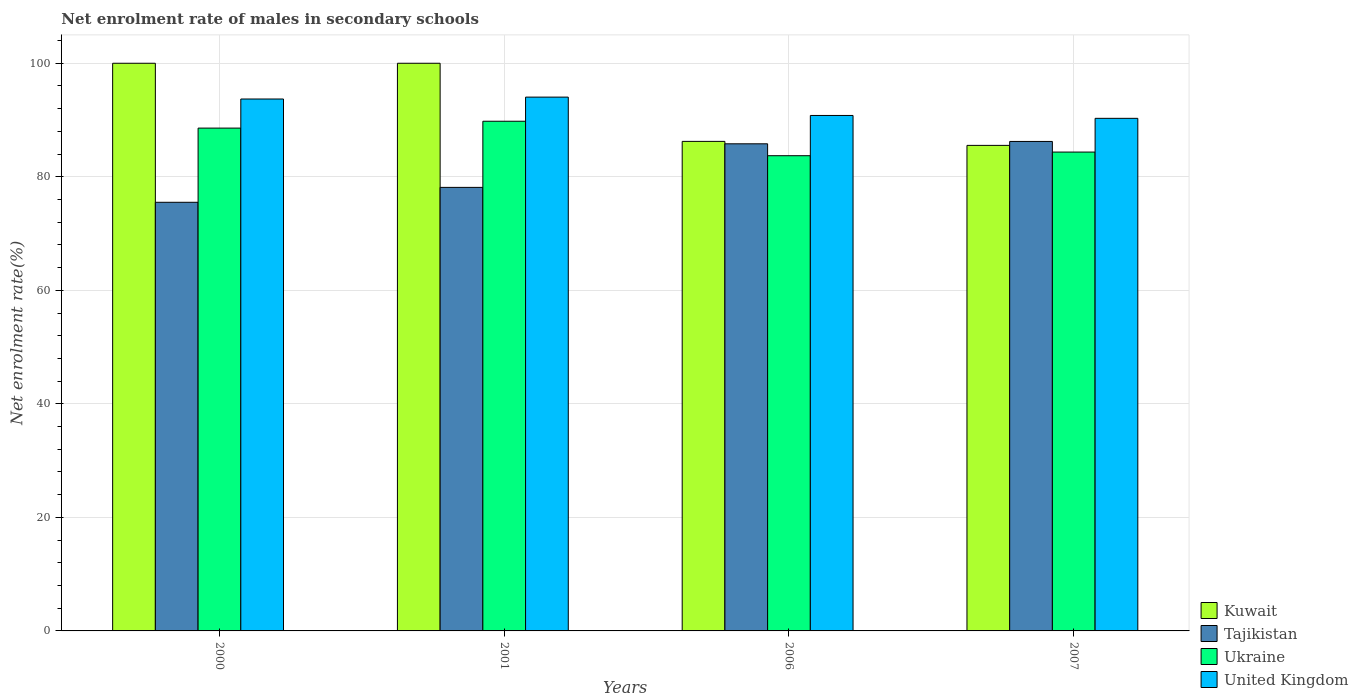Are the number of bars per tick equal to the number of legend labels?
Your response must be concise. Yes. What is the label of the 1st group of bars from the left?
Provide a short and direct response. 2000. What is the net enrolment rate of males in secondary schools in United Kingdom in 2006?
Your answer should be compact. 90.8. Across all years, what is the maximum net enrolment rate of males in secondary schools in Ukraine?
Provide a succinct answer. 89.79. Across all years, what is the minimum net enrolment rate of males in secondary schools in Tajikistan?
Keep it short and to the point. 75.51. In which year was the net enrolment rate of males in secondary schools in Tajikistan minimum?
Provide a short and direct response. 2000. What is the total net enrolment rate of males in secondary schools in Kuwait in the graph?
Your answer should be very brief. 371.77. What is the difference between the net enrolment rate of males in secondary schools in Ukraine in 2000 and that in 2007?
Your response must be concise. 4.22. What is the difference between the net enrolment rate of males in secondary schools in Kuwait in 2000 and the net enrolment rate of males in secondary schools in Tajikistan in 2007?
Offer a very short reply. 13.77. What is the average net enrolment rate of males in secondary schools in Kuwait per year?
Offer a very short reply. 92.94. In the year 2007, what is the difference between the net enrolment rate of males in secondary schools in Tajikistan and net enrolment rate of males in secondary schools in Kuwait?
Your response must be concise. 0.69. What is the ratio of the net enrolment rate of males in secondary schools in Kuwait in 2000 to that in 2006?
Your answer should be very brief. 1.16. Is the net enrolment rate of males in secondary schools in Kuwait in 2000 less than that in 2006?
Give a very brief answer. No. Is the difference between the net enrolment rate of males in secondary schools in Tajikistan in 2001 and 2007 greater than the difference between the net enrolment rate of males in secondary schools in Kuwait in 2001 and 2007?
Offer a very short reply. No. What is the difference between the highest and the second highest net enrolment rate of males in secondary schools in Ukraine?
Offer a very short reply. 1.21. What is the difference between the highest and the lowest net enrolment rate of males in secondary schools in Ukraine?
Your answer should be very brief. 6.07. In how many years, is the net enrolment rate of males in secondary schools in Kuwait greater than the average net enrolment rate of males in secondary schools in Kuwait taken over all years?
Your answer should be very brief. 2. Is the sum of the net enrolment rate of males in secondary schools in Tajikistan in 2000 and 2007 greater than the maximum net enrolment rate of males in secondary schools in Ukraine across all years?
Offer a very short reply. Yes. What does the 2nd bar from the left in 2006 represents?
Give a very brief answer. Tajikistan. What does the 2nd bar from the right in 2006 represents?
Your answer should be compact. Ukraine. How many bars are there?
Ensure brevity in your answer.  16. Are the values on the major ticks of Y-axis written in scientific E-notation?
Your answer should be compact. No. Does the graph contain any zero values?
Make the answer very short. No. Where does the legend appear in the graph?
Give a very brief answer. Bottom right. What is the title of the graph?
Give a very brief answer. Net enrolment rate of males in secondary schools. What is the label or title of the X-axis?
Your answer should be very brief. Years. What is the label or title of the Y-axis?
Provide a succinct answer. Net enrolment rate(%). What is the Net enrolment rate(%) in Tajikistan in 2000?
Make the answer very short. 75.51. What is the Net enrolment rate(%) of Ukraine in 2000?
Provide a short and direct response. 88.58. What is the Net enrolment rate(%) of United Kingdom in 2000?
Offer a terse response. 93.7. What is the Net enrolment rate(%) of Tajikistan in 2001?
Ensure brevity in your answer.  78.13. What is the Net enrolment rate(%) in Ukraine in 2001?
Give a very brief answer. 89.79. What is the Net enrolment rate(%) of United Kingdom in 2001?
Provide a short and direct response. 94.04. What is the Net enrolment rate(%) of Kuwait in 2006?
Provide a succinct answer. 86.24. What is the Net enrolment rate(%) of Tajikistan in 2006?
Provide a succinct answer. 85.81. What is the Net enrolment rate(%) of Ukraine in 2006?
Your response must be concise. 83.71. What is the Net enrolment rate(%) of United Kingdom in 2006?
Provide a short and direct response. 90.8. What is the Net enrolment rate(%) in Kuwait in 2007?
Provide a succinct answer. 85.53. What is the Net enrolment rate(%) in Tajikistan in 2007?
Your answer should be compact. 86.23. What is the Net enrolment rate(%) of Ukraine in 2007?
Provide a succinct answer. 84.36. What is the Net enrolment rate(%) of United Kingdom in 2007?
Ensure brevity in your answer.  90.3. Across all years, what is the maximum Net enrolment rate(%) in Kuwait?
Give a very brief answer. 100. Across all years, what is the maximum Net enrolment rate(%) in Tajikistan?
Your answer should be compact. 86.23. Across all years, what is the maximum Net enrolment rate(%) in Ukraine?
Offer a terse response. 89.79. Across all years, what is the maximum Net enrolment rate(%) of United Kingdom?
Provide a succinct answer. 94.04. Across all years, what is the minimum Net enrolment rate(%) of Kuwait?
Your response must be concise. 85.53. Across all years, what is the minimum Net enrolment rate(%) in Tajikistan?
Offer a terse response. 75.51. Across all years, what is the minimum Net enrolment rate(%) in Ukraine?
Give a very brief answer. 83.71. Across all years, what is the minimum Net enrolment rate(%) in United Kingdom?
Offer a terse response. 90.3. What is the total Net enrolment rate(%) of Kuwait in the graph?
Keep it short and to the point. 371.77. What is the total Net enrolment rate(%) in Tajikistan in the graph?
Offer a very short reply. 325.68. What is the total Net enrolment rate(%) of Ukraine in the graph?
Keep it short and to the point. 346.43. What is the total Net enrolment rate(%) of United Kingdom in the graph?
Keep it short and to the point. 368.84. What is the difference between the Net enrolment rate(%) of Kuwait in 2000 and that in 2001?
Provide a short and direct response. 0. What is the difference between the Net enrolment rate(%) in Tajikistan in 2000 and that in 2001?
Provide a succinct answer. -2.63. What is the difference between the Net enrolment rate(%) of Ukraine in 2000 and that in 2001?
Give a very brief answer. -1.21. What is the difference between the Net enrolment rate(%) of United Kingdom in 2000 and that in 2001?
Your response must be concise. -0.33. What is the difference between the Net enrolment rate(%) in Kuwait in 2000 and that in 2006?
Provide a succinct answer. 13.76. What is the difference between the Net enrolment rate(%) in Tajikistan in 2000 and that in 2006?
Offer a terse response. -10.3. What is the difference between the Net enrolment rate(%) of Ukraine in 2000 and that in 2006?
Your response must be concise. 4.86. What is the difference between the Net enrolment rate(%) in Kuwait in 2000 and that in 2007?
Provide a short and direct response. 14.47. What is the difference between the Net enrolment rate(%) in Tajikistan in 2000 and that in 2007?
Provide a succinct answer. -10.72. What is the difference between the Net enrolment rate(%) of Ukraine in 2000 and that in 2007?
Ensure brevity in your answer.  4.22. What is the difference between the Net enrolment rate(%) in United Kingdom in 2000 and that in 2007?
Your answer should be compact. 3.41. What is the difference between the Net enrolment rate(%) in Kuwait in 2001 and that in 2006?
Offer a terse response. 13.76. What is the difference between the Net enrolment rate(%) in Tajikistan in 2001 and that in 2006?
Give a very brief answer. -7.68. What is the difference between the Net enrolment rate(%) of Ukraine in 2001 and that in 2006?
Your response must be concise. 6.07. What is the difference between the Net enrolment rate(%) of United Kingdom in 2001 and that in 2006?
Give a very brief answer. 3.23. What is the difference between the Net enrolment rate(%) in Kuwait in 2001 and that in 2007?
Your response must be concise. 14.47. What is the difference between the Net enrolment rate(%) in Tajikistan in 2001 and that in 2007?
Your answer should be very brief. -8.09. What is the difference between the Net enrolment rate(%) of Ukraine in 2001 and that in 2007?
Provide a succinct answer. 5.43. What is the difference between the Net enrolment rate(%) of United Kingdom in 2001 and that in 2007?
Offer a terse response. 3.74. What is the difference between the Net enrolment rate(%) in Kuwait in 2006 and that in 2007?
Your answer should be compact. 0.7. What is the difference between the Net enrolment rate(%) of Tajikistan in 2006 and that in 2007?
Make the answer very short. -0.42. What is the difference between the Net enrolment rate(%) in Ukraine in 2006 and that in 2007?
Your response must be concise. -0.64. What is the difference between the Net enrolment rate(%) of United Kingdom in 2006 and that in 2007?
Offer a terse response. 0.51. What is the difference between the Net enrolment rate(%) of Kuwait in 2000 and the Net enrolment rate(%) of Tajikistan in 2001?
Provide a succinct answer. 21.87. What is the difference between the Net enrolment rate(%) in Kuwait in 2000 and the Net enrolment rate(%) in Ukraine in 2001?
Provide a short and direct response. 10.21. What is the difference between the Net enrolment rate(%) of Kuwait in 2000 and the Net enrolment rate(%) of United Kingdom in 2001?
Provide a short and direct response. 5.96. What is the difference between the Net enrolment rate(%) in Tajikistan in 2000 and the Net enrolment rate(%) in Ukraine in 2001?
Offer a very short reply. -14.28. What is the difference between the Net enrolment rate(%) in Tajikistan in 2000 and the Net enrolment rate(%) in United Kingdom in 2001?
Provide a short and direct response. -18.53. What is the difference between the Net enrolment rate(%) in Ukraine in 2000 and the Net enrolment rate(%) in United Kingdom in 2001?
Ensure brevity in your answer.  -5.46. What is the difference between the Net enrolment rate(%) of Kuwait in 2000 and the Net enrolment rate(%) of Tajikistan in 2006?
Ensure brevity in your answer.  14.19. What is the difference between the Net enrolment rate(%) in Kuwait in 2000 and the Net enrolment rate(%) in Ukraine in 2006?
Give a very brief answer. 16.29. What is the difference between the Net enrolment rate(%) in Kuwait in 2000 and the Net enrolment rate(%) in United Kingdom in 2006?
Keep it short and to the point. 9.2. What is the difference between the Net enrolment rate(%) of Tajikistan in 2000 and the Net enrolment rate(%) of Ukraine in 2006?
Provide a succinct answer. -8.2. What is the difference between the Net enrolment rate(%) of Tajikistan in 2000 and the Net enrolment rate(%) of United Kingdom in 2006?
Offer a very short reply. -15.29. What is the difference between the Net enrolment rate(%) of Ukraine in 2000 and the Net enrolment rate(%) of United Kingdom in 2006?
Make the answer very short. -2.23. What is the difference between the Net enrolment rate(%) in Kuwait in 2000 and the Net enrolment rate(%) in Tajikistan in 2007?
Your response must be concise. 13.77. What is the difference between the Net enrolment rate(%) of Kuwait in 2000 and the Net enrolment rate(%) of Ukraine in 2007?
Provide a short and direct response. 15.64. What is the difference between the Net enrolment rate(%) of Kuwait in 2000 and the Net enrolment rate(%) of United Kingdom in 2007?
Offer a terse response. 9.7. What is the difference between the Net enrolment rate(%) in Tajikistan in 2000 and the Net enrolment rate(%) in Ukraine in 2007?
Keep it short and to the point. -8.85. What is the difference between the Net enrolment rate(%) of Tajikistan in 2000 and the Net enrolment rate(%) of United Kingdom in 2007?
Your answer should be very brief. -14.79. What is the difference between the Net enrolment rate(%) in Ukraine in 2000 and the Net enrolment rate(%) in United Kingdom in 2007?
Your answer should be compact. -1.72. What is the difference between the Net enrolment rate(%) in Kuwait in 2001 and the Net enrolment rate(%) in Tajikistan in 2006?
Make the answer very short. 14.19. What is the difference between the Net enrolment rate(%) in Kuwait in 2001 and the Net enrolment rate(%) in Ukraine in 2006?
Keep it short and to the point. 16.29. What is the difference between the Net enrolment rate(%) in Kuwait in 2001 and the Net enrolment rate(%) in United Kingdom in 2006?
Provide a short and direct response. 9.2. What is the difference between the Net enrolment rate(%) in Tajikistan in 2001 and the Net enrolment rate(%) in Ukraine in 2006?
Provide a succinct answer. -5.58. What is the difference between the Net enrolment rate(%) of Tajikistan in 2001 and the Net enrolment rate(%) of United Kingdom in 2006?
Provide a succinct answer. -12.67. What is the difference between the Net enrolment rate(%) in Ukraine in 2001 and the Net enrolment rate(%) in United Kingdom in 2006?
Provide a succinct answer. -1.02. What is the difference between the Net enrolment rate(%) in Kuwait in 2001 and the Net enrolment rate(%) in Tajikistan in 2007?
Offer a very short reply. 13.77. What is the difference between the Net enrolment rate(%) of Kuwait in 2001 and the Net enrolment rate(%) of Ukraine in 2007?
Your answer should be compact. 15.64. What is the difference between the Net enrolment rate(%) in Kuwait in 2001 and the Net enrolment rate(%) in United Kingdom in 2007?
Your response must be concise. 9.7. What is the difference between the Net enrolment rate(%) in Tajikistan in 2001 and the Net enrolment rate(%) in Ukraine in 2007?
Your answer should be compact. -6.22. What is the difference between the Net enrolment rate(%) of Tajikistan in 2001 and the Net enrolment rate(%) of United Kingdom in 2007?
Provide a succinct answer. -12.16. What is the difference between the Net enrolment rate(%) in Ukraine in 2001 and the Net enrolment rate(%) in United Kingdom in 2007?
Your response must be concise. -0.51. What is the difference between the Net enrolment rate(%) of Kuwait in 2006 and the Net enrolment rate(%) of Tajikistan in 2007?
Give a very brief answer. 0.01. What is the difference between the Net enrolment rate(%) of Kuwait in 2006 and the Net enrolment rate(%) of Ukraine in 2007?
Ensure brevity in your answer.  1.88. What is the difference between the Net enrolment rate(%) in Kuwait in 2006 and the Net enrolment rate(%) in United Kingdom in 2007?
Keep it short and to the point. -4.06. What is the difference between the Net enrolment rate(%) in Tajikistan in 2006 and the Net enrolment rate(%) in Ukraine in 2007?
Provide a succinct answer. 1.46. What is the difference between the Net enrolment rate(%) of Tajikistan in 2006 and the Net enrolment rate(%) of United Kingdom in 2007?
Ensure brevity in your answer.  -4.49. What is the difference between the Net enrolment rate(%) in Ukraine in 2006 and the Net enrolment rate(%) in United Kingdom in 2007?
Your response must be concise. -6.58. What is the average Net enrolment rate(%) of Kuwait per year?
Ensure brevity in your answer.  92.94. What is the average Net enrolment rate(%) in Tajikistan per year?
Keep it short and to the point. 81.42. What is the average Net enrolment rate(%) in Ukraine per year?
Offer a terse response. 86.61. What is the average Net enrolment rate(%) of United Kingdom per year?
Provide a short and direct response. 92.21. In the year 2000, what is the difference between the Net enrolment rate(%) in Kuwait and Net enrolment rate(%) in Tajikistan?
Make the answer very short. 24.49. In the year 2000, what is the difference between the Net enrolment rate(%) in Kuwait and Net enrolment rate(%) in Ukraine?
Provide a short and direct response. 11.42. In the year 2000, what is the difference between the Net enrolment rate(%) in Kuwait and Net enrolment rate(%) in United Kingdom?
Make the answer very short. 6.3. In the year 2000, what is the difference between the Net enrolment rate(%) of Tajikistan and Net enrolment rate(%) of Ukraine?
Give a very brief answer. -13.07. In the year 2000, what is the difference between the Net enrolment rate(%) in Tajikistan and Net enrolment rate(%) in United Kingdom?
Keep it short and to the point. -18.19. In the year 2000, what is the difference between the Net enrolment rate(%) of Ukraine and Net enrolment rate(%) of United Kingdom?
Offer a very short reply. -5.13. In the year 2001, what is the difference between the Net enrolment rate(%) in Kuwait and Net enrolment rate(%) in Tajikistan?
Give a very brief answer. 21.87. In the year 2001, what is the difference between the Net enrolment rate(%) of Kuwait and Net enrolment rate(%) of Ukraine?
Ensure brevity in your answer.  10.21. In the year 2001, what is the difference between the Net enrolment rate(%) of Kuwait and Net enrolment rate(%) of United Kingdom?
Give a very brief answer. 5.96. In the year 2001, what is the difference between the Net enrolment rate(%) of Tajikistan and Net enrolment rate(%) of Ukraine?
Your answer should be compact. -11.65. In the year 2001, what is the difference between the Net enrolment rate(%) in Tajikistan and Net enrolment rate(%) in United Kingdom?
Make the answer very short. -15.9. In the year 2001, what is the difference between the Net enrolment rate(%) in Ukraine and Net enrolment rate(%) in United Kingdom?
Your response must be concise. -4.25. In the year 2006, what is the difference between the Net enrolment rate(%) in Kuwait and Net enrolment rate(%) in Tajikistan?
Offer a terse response. 0.43. In the year 2006, what is the difference between the Net enrolment rate(%) of Kuwait and Net enrolment rate(%) of Ukraine?
Your answer should be very brief. 2.52. In the year 2006, what is the difference between the Net enrolment rate(%) of Kuwait and Net enrolment rate(%) of United Kingdom?
Give a very brief answer. -4.57. In the year 2006, what is the difference between the Net enrolment rate(%) in Tajikistan and Net enrolment rate(%) in Ukraine?
Your answer should be very brief. 2.1. In the year 2006, what is the difference between the Net enrolment rate(%) in Tajikistan and Net enrolment rate(%) in United Kingdom?
Keep it short and to the point. -4.99. In the year 2006, what is the difference between the Net enrolment rate(%) of Ukraine and Net enrolment rate(%) of United Kingdom?
Your answer should be very brief. -7.09. In the year 2007, what is the difference between the Net enrolment rate(%) in Kuwait and Net enrolment rate(%) in Tajikistan?
Offer a very short reply. -0.69. In the year 2007, what is the difference between the Net enrolment rate(%) in Kuwait and Net enrolment rate(%) in Ukraine?
Offer a terse response. 1.18. In the year 2007, what is the difference between the Net enrolment rate(%) in Kuwait and Net enrolment rate(%) in United Kingdom?
Provide a succinct answer. -4.76. In the year 2007, what is the difference between the Net enrolment rate(%) of Tajikistan and Net enrolment rate(%) of Ukraine?
Give a very brief answer. 1.87. In the year 2007, what is the difference between the Net enrolment rate(%) of Tajikistan and Net enrolment rate(%) of United Kingdom?
Your answer should be very brief. -4.07. In the year 2007, what is the difference between the Net enrolment rate(%) in Ukraine and Net enrolment rate(%) in United Kingdom?
Your answer should be very brief. -5.94. What is the ratio of the Net enrolment rate(%) of Kuwait in 2000 to that in 2001?
Keep it short and to the point. 1. What is the ratio of the Net enrolment rate(%) of Tajikistan in 2000 to that in 2001?
Provide a short and direct response. 0.97. What is the ratio of the Net enrolment rate(%) of Ukraine in 2000 to that in 2001?
Provide a short and direct response. 0.99. What is the ratio of the Net enrolment rate(%) in Kuwait in 2000 to that in 2006?
Your response must be concise. 1.16. What is the ratio of the Net enrolment rate(%) in Tajikistan in 2000 to that in 2006?
Offer a terse response. 0.88. What is the ratio of the Net enrolment rate(%) of Ukraine in 2000 to that in 2006?
Offer a very short reply. 1.06. What is the ratio of the Net enrolment rate(%) of United Kingdom in 2000 to that in 2006?
Your answer should be very brief. 1.03. What is the ratio of the Net enrolment rate(%) in Kuwait in 2000 to that in 2007?
Your answer should be very brief. 1.17. What is the ratio of the Net enrolment rate(%) of Tajikistan in 2000 to that in 2007?
Your answer should be compact. 0.88. What is the ratio of the Net enrolment rate(%) of Ukraine in 2000 to that in 2007?
Offer a very short reply. 1.05. What is the ratio of the Net enrolment rate(%) of United Kingdom in 2000 to that in 2007?
Keep it short and to the point. 1.04. What is the ratio of the Net enrolment rate(%) of Kuwait in 2001 to that in 2006?
Offer a terse response. 1.16. What is the ratio of the Net enrolment rate(%) of Tajikistan in 2001 to that in 2006?
Make the answer very short. 0.91. What is the ratio of the Net enrolment rate(%) of Ukraine in 2001 to that in 2006?
Offer a very short reply. 1.07. What is the ratio of the Net enrolment rate(%) in United Kingdom in 2001 to that in 2006?
Make the answer very short. 1.04. What is the ratio of the Net enrolment rate(%) of Kuwait in 2001 to that in 2007?
Provide a short and direct response. 1.17. What is the ratio of the Net enrolment rate(%) in Tajikistan in 2001 to that in 2007?
Keep it short and to the point. 0.91. What is the ratio of the Net enrolment rate(%) of Ukraine in 2001 to that in 2007?
Your answer should be very brief. 1.06. What is the ratio of the Net enrolment rate(%) in United Kingdom in 2001 to that in 2007?
Offer a terse response. 1.04. What is the ratio of the Net enrolment rate(%) of Kuwait in 2006 to that in 2007?
Your answer should be very brief. 1.01. What is the ratio of the Net enrolment rate(%) in Tajikistan in 2006 to that in 2007?
Offer a very short reply. 1. What is the ratio of the Net enrolment rate(%) of Ukraine in 2006 to that in 2007?
Your response must be concise. 0.99. What is the ratio of the Net enrolment rate(%) in United Kingdom in 2006 to that in 2007?
Give a very brief answer. 1.01. What is the difference between the highest and the second highest Net enrolment rate(%) of Kuwait?
Provide a succinct answer. 0. What is the difference between the highest and the second highest Net enrolment rate(%) of Tajikistan?
Offer a terse response. 0.42. What is the difference between the highest and the second highest Net enrolment rate(%) in Ukraine?
Provide a succinct answer. 1.21. What is the difference between the highest and the second highest Net enrolment rate(%) of United Kingdom?
Your answer should be compact. 0.33. What is the difference between the highest and the lowest Net enrolment rate(%) of Kuwait?
Provide a succinct answer. 14.47. What is the difference between the highest and the lowest Net enrolment rate(%) in Tajikistan?
Keep it short and to the point. 10.72. What is the difference between the highest and the lowest Net enrolment rate(%) in Ukraine?
Your answer should be compact. 6.07. What is the difference between the highest and the lowest Net enrolment rate(%) in United Kingdom?
Offer a terse response. 3.74. 